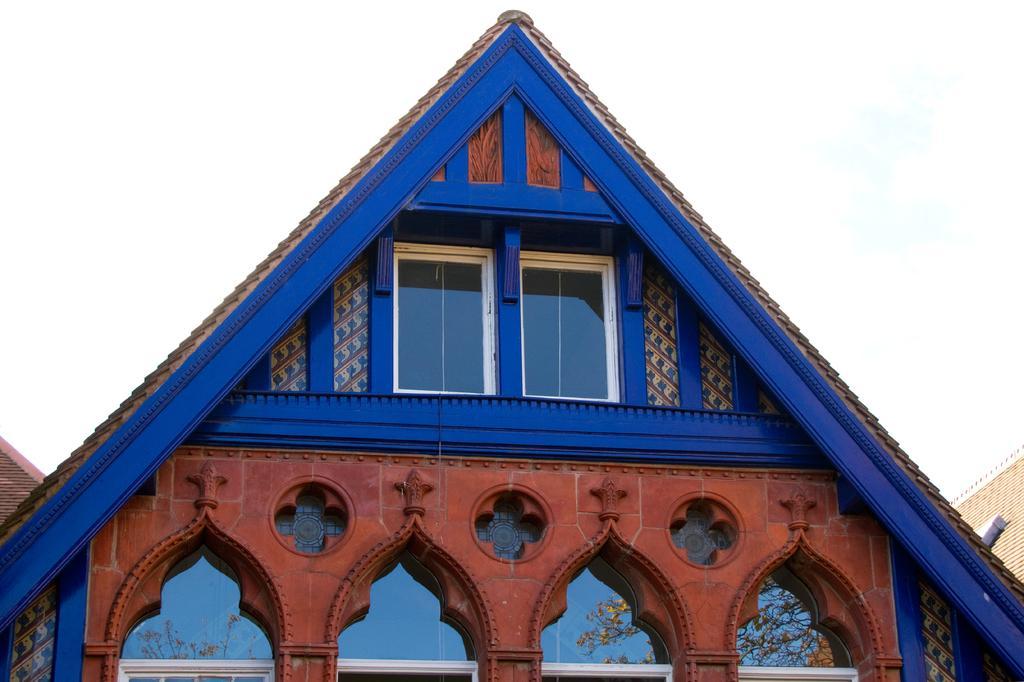In one or two sentences, can you explain what this image depicts? In this image we can see the houses and in the background, we can see the sky. 